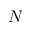Convert formula to latex. <formula><loc_0><loc_0><loc_500><loc_500>N</formula> 